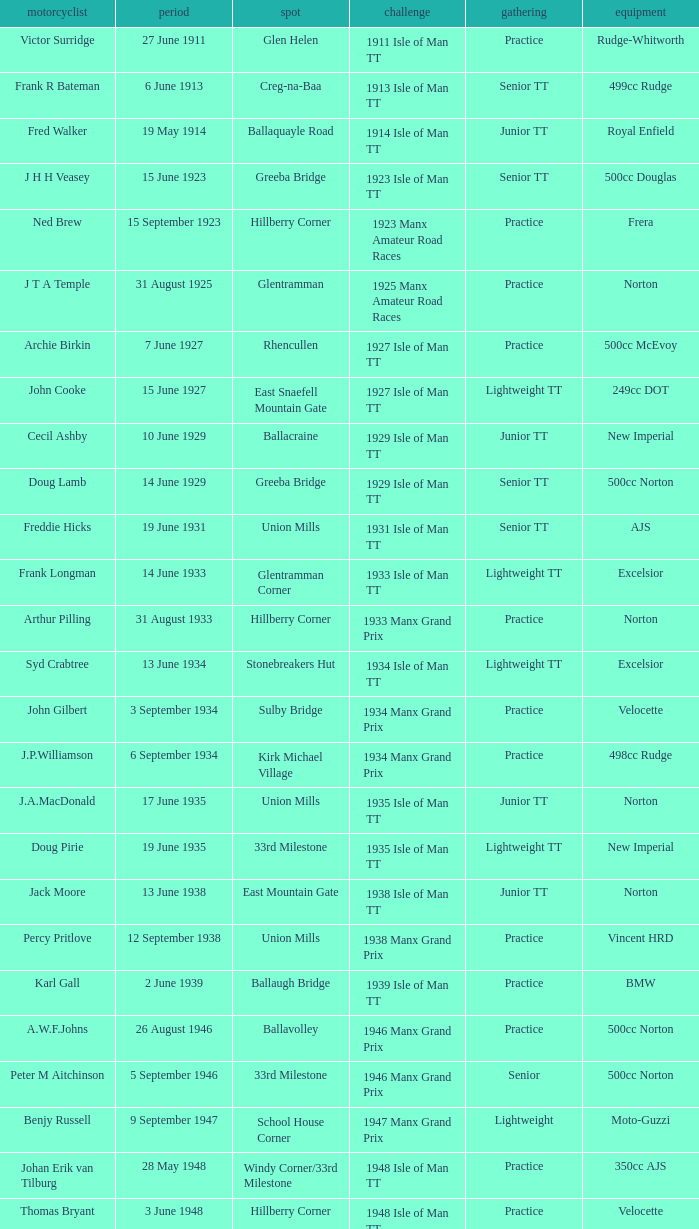What machine did Kenneth E. Herbert ride? 499cc Norton. 